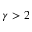Convert formula to latex. <formula><loc_0><loc_0><loc_500><loc_500>\gamma > 2</formula> 